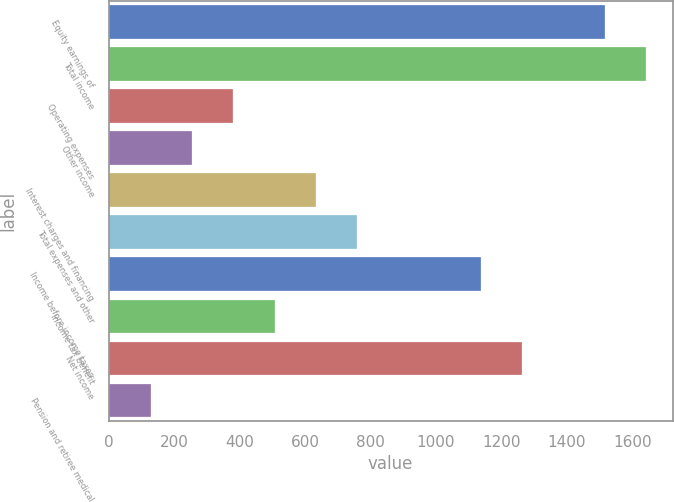Convert chart. <chart><loc_0><loc_0><loc_500><loc_500><bar_chart><fcel>Equity earnings of<fcel>Total income<fcel>Operating expenses<fcel>Other income<fcel>Interest charges and financing<fcel>Total expenses and other<fcel>Income before income taxes<fcel>Income tax benefit<fcel>Net income<fcel>Pension and retiree medical<nl><fcel>1515<fcel>1641<fcel>381<fcel>255<fcel>633<fcel>759<fcel>1137<fcel>507<fcel>1263<fcel>129<nl></chart> 